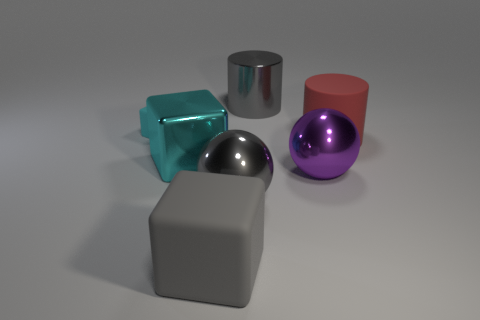Subtract all gray cubes. How many cubes are left? 2 Add 2 tiny gray rubber blocks. How many objects exist? 9 Subtract all gray matte blocks. How many blocks are left? 2 Subtract 0 green spheres. How many objects are left? 7 Subtract all blocks. How many objects are left? 4 Subtract 1 cylinders. How many cylinders are left? 1 Subtract all cyan balls. Subtract all yellow cylinders. How many balls are left? 2 Subtract all green cylinders. How many gray balls are left? 1 Subtract all large cubes. Subtract all big cylinders. How many objects are left? 3 Add 5 big shiny things. How many big shiny things are left? 9 